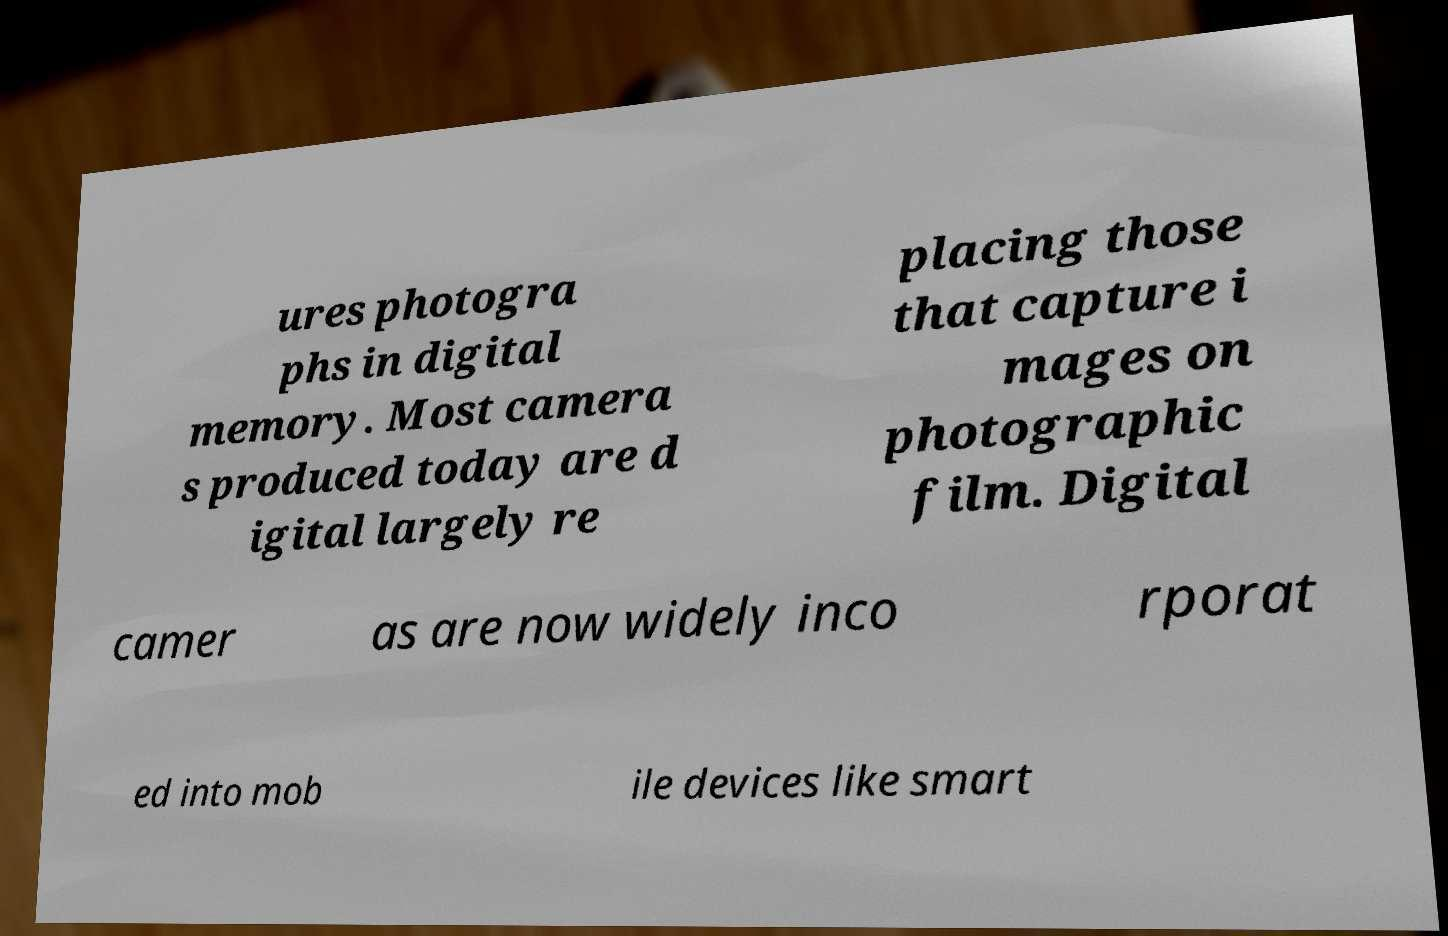For documentation purposes, I need the text within this image transcribed. Could you provide that? ures photogra phs in digital memory. Most camera s produced today are d igital largely re placing those that capture i mages on photographic film. Digital camer as are now widely inco rporat ed into mob ile devices like smart 